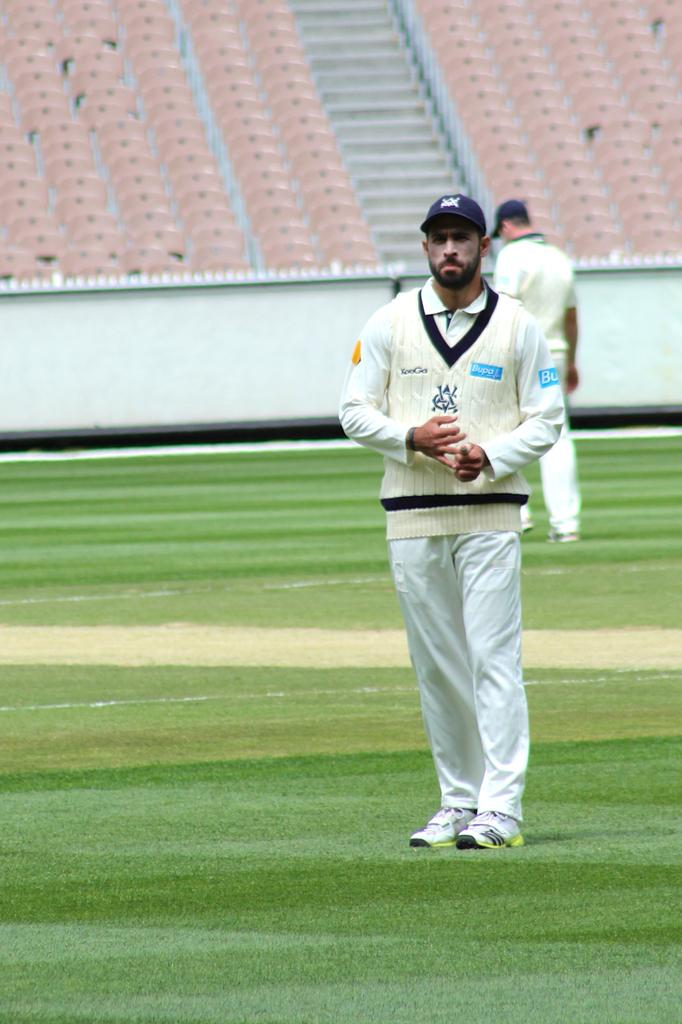<image>
Share a concise interpretation of the image provided. A man stands in a field wearing mostly white with a blue Bupo logo on the shirt. 